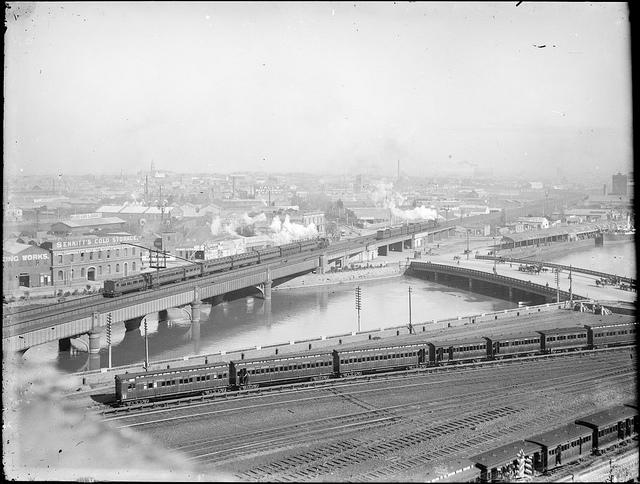Is this a train station?
Write a very short answer. No. What type of train is this?
Be succinct. Passenger. What is in the water?
Quick response, please. Fish. Is this picture in color?
Write a very short answer. No. Is the train crossing a long bridge?
Short answer required. Yes. Where is this picture taken from?
Quick response, please. Above. Is there water?
Be succinct. Yes. 